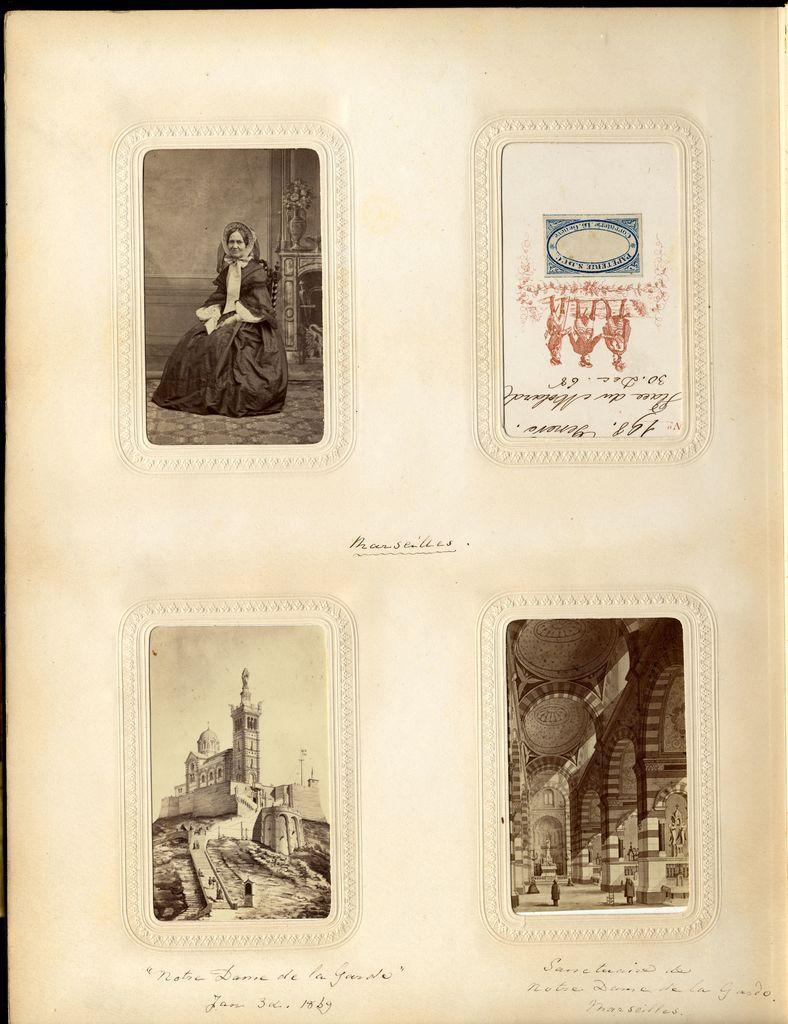In one or two sentences, can you explain what this image depicts? In this image I can see there are images on the paper. At the top a woman is there, at the bottom there is the fort. 